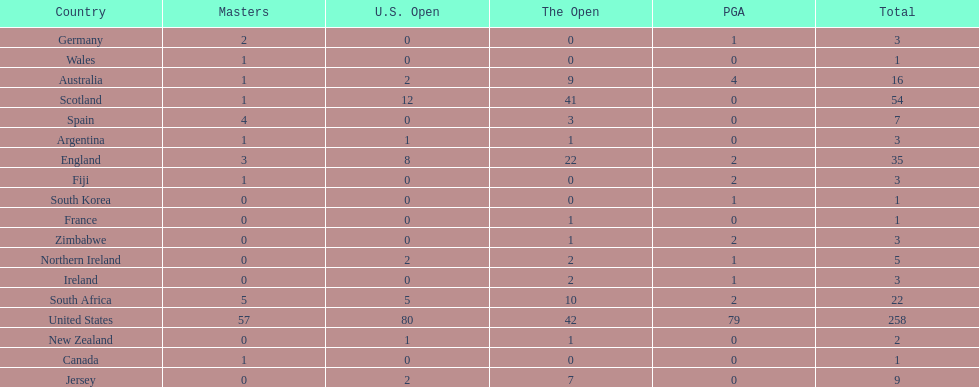Parse the full table. {'header': ['Country', 'Masters', 'U.S. Open', 'The Open', 'PGA', 'Total'], 'rows': [['Germany', '2', '0', '0', '1', '3'], ['Wales', '1', '0', '0', '0', '1'], ['Australia', '1', '2', '9', '4', '16'], ['Scotland', '1', '12', '41', '0', '54'], ['Spain', '4', '0', '3', '0', '7'], ['Argentina', '1', '1', '1', '0', '3'], ['England', '3', '8', '22', '2', '35'], ['Fiji', '1', '0', '0', '2', '3'], ['South Korea', '0', '0', '0', '1', '1'], ['France', '0', '0', '1', '0', '1'], ['Zimbabwe', '0', '0', '1', '2', '3'], ['Northern Ireland', '0', '2', '2', '1', '5'], ['Ireland', '0', '0', '2', '1', '3'], ['South Africa', '5', '5', '10', '2', '22'], ['United States', '57', '80', '42', '79', '258'], ['New Zealand', '0', '1', '1', '0', '2'], ['Canada', '1', '0', '0', '0', '1'], ['Jersey', '0', '2', '7', '0', '9']]} How many u.s. open wins does fiji have? 0. 